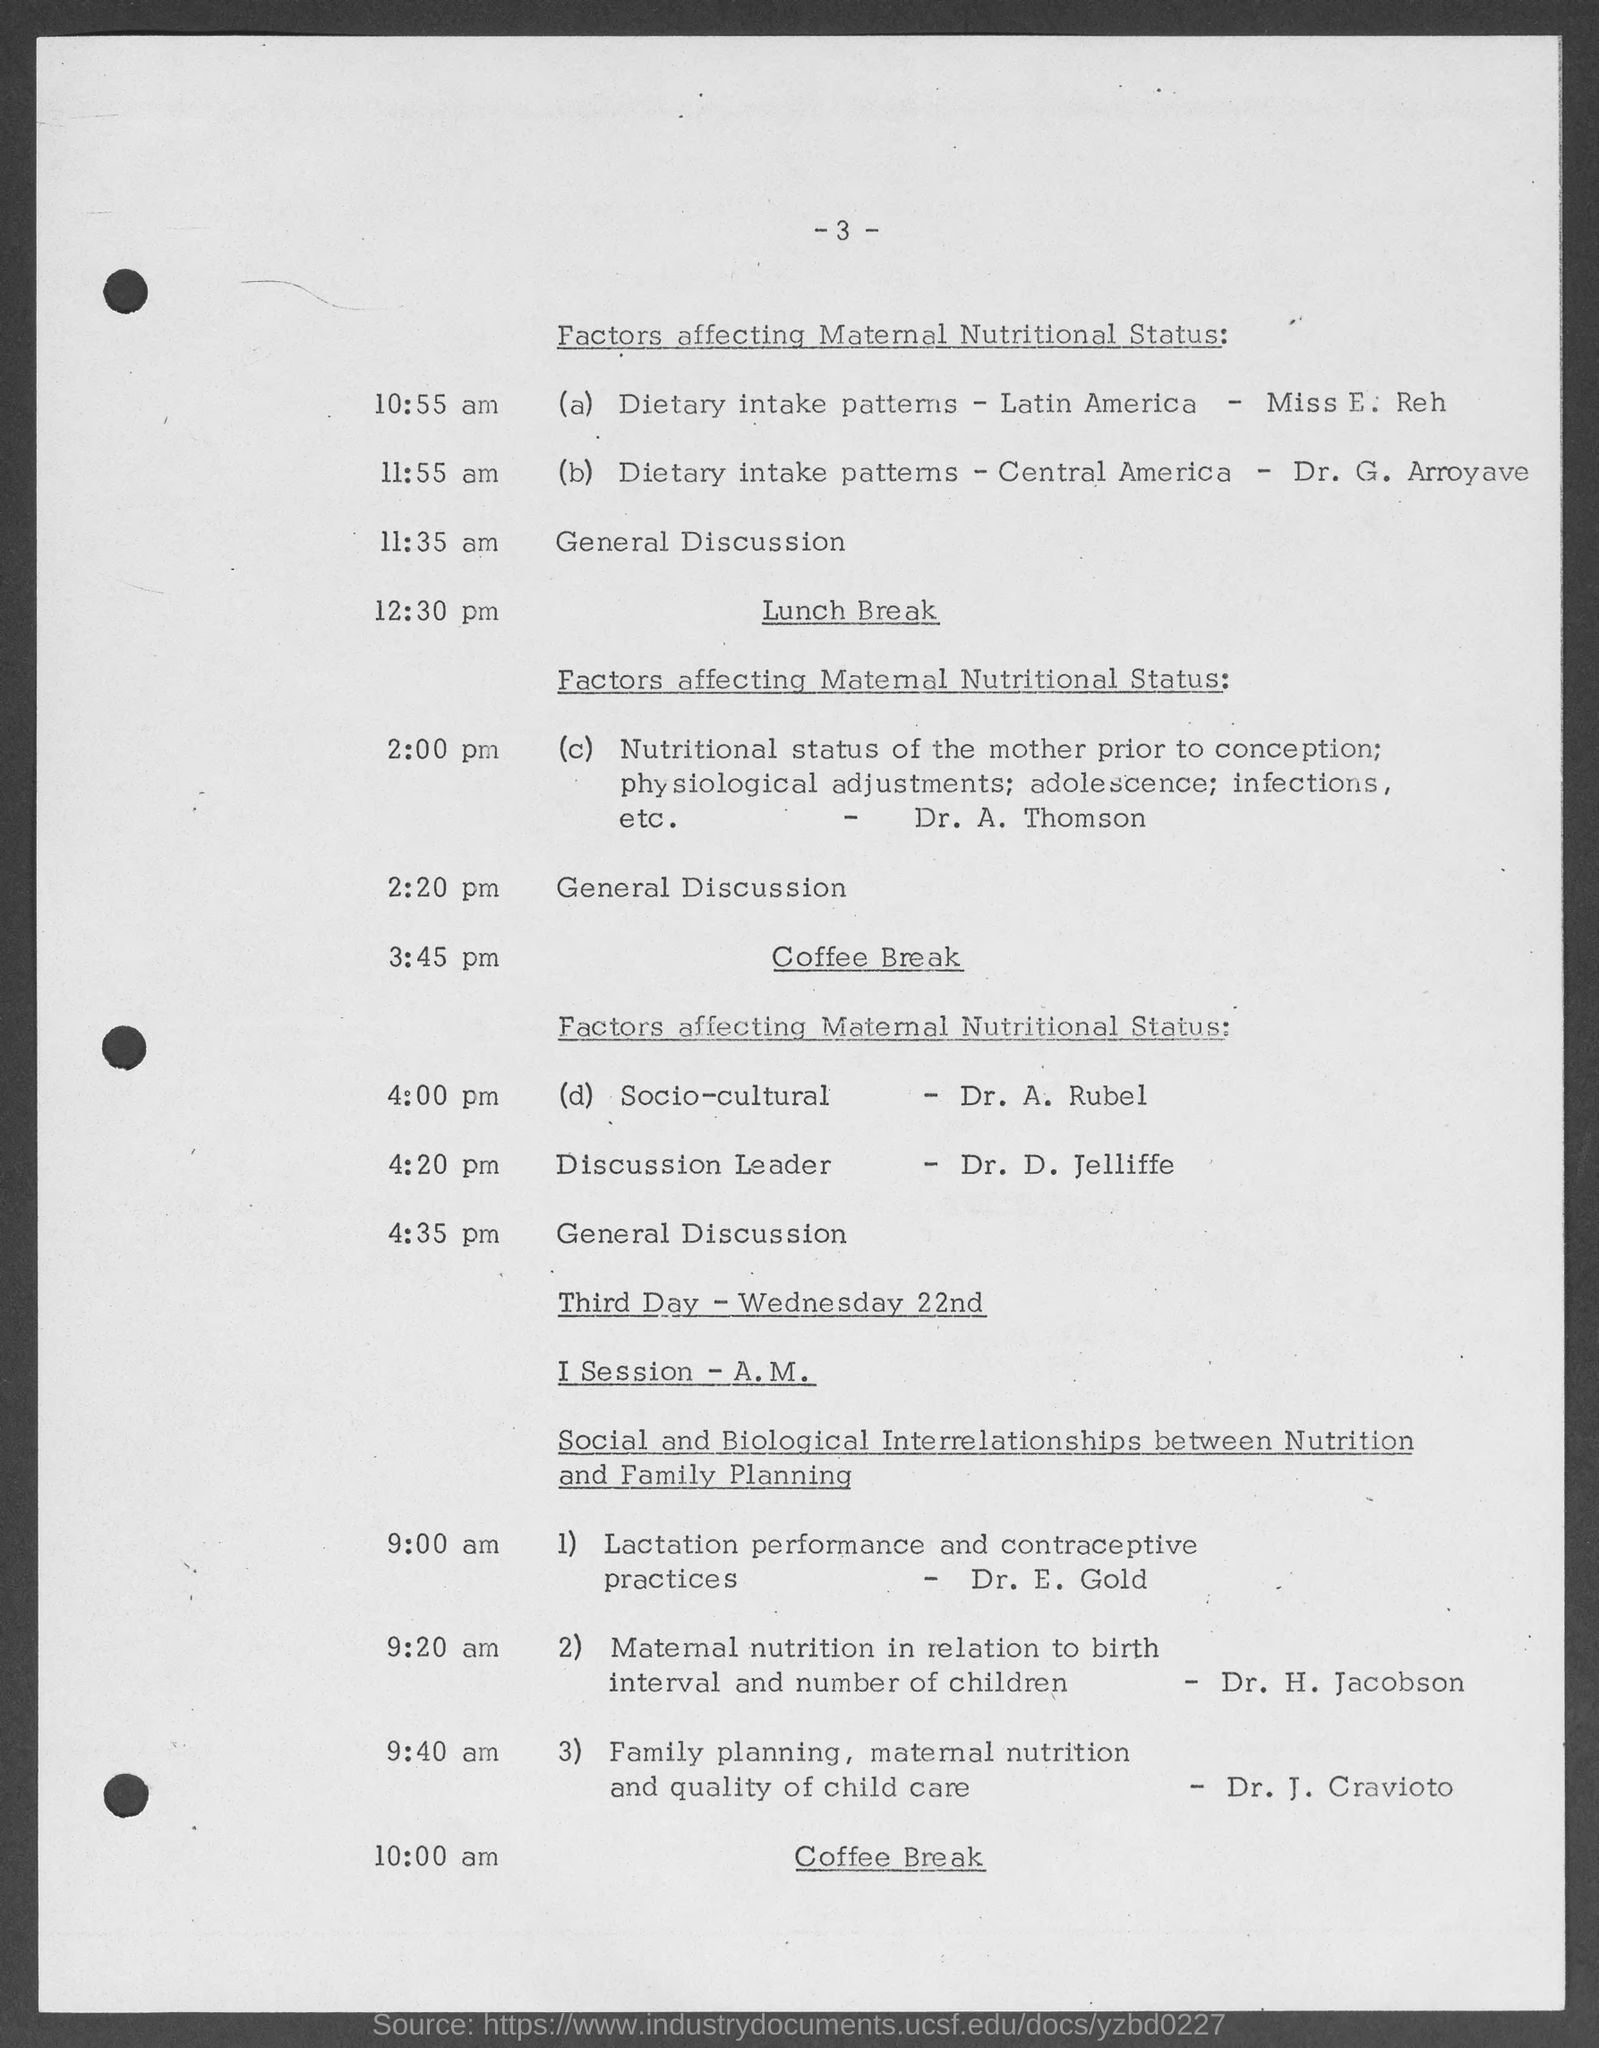What is the topic after lunch break?
Ensure brevity in your answer.  Factors affecting maternal nutritional status. What time is the coffee break on third day?
Your answer should be compact. 10:00 am. 